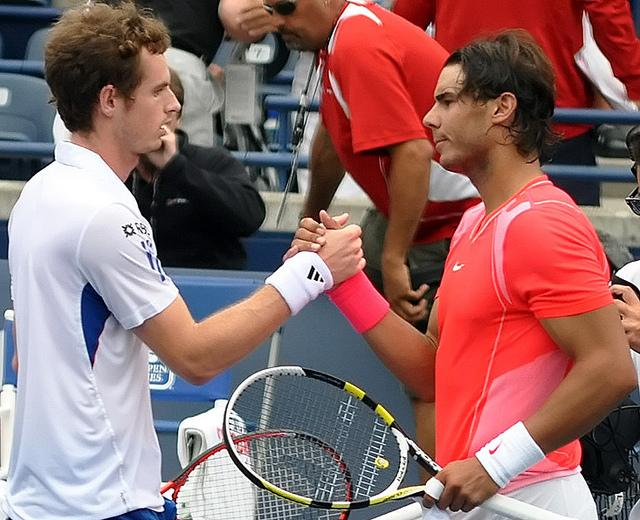What did the two men shaking hands just do? play tennis 